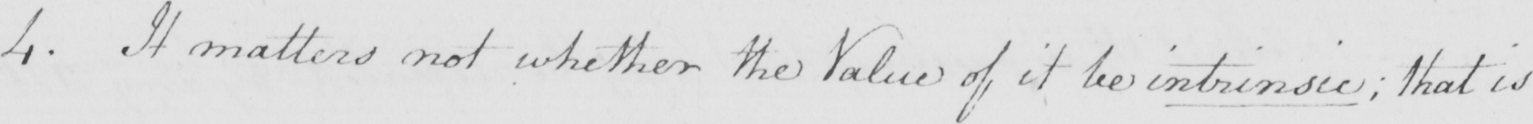What text is written in this handwritten line? 4 . It matters not whether the Value of it be intrinsic ; that is 